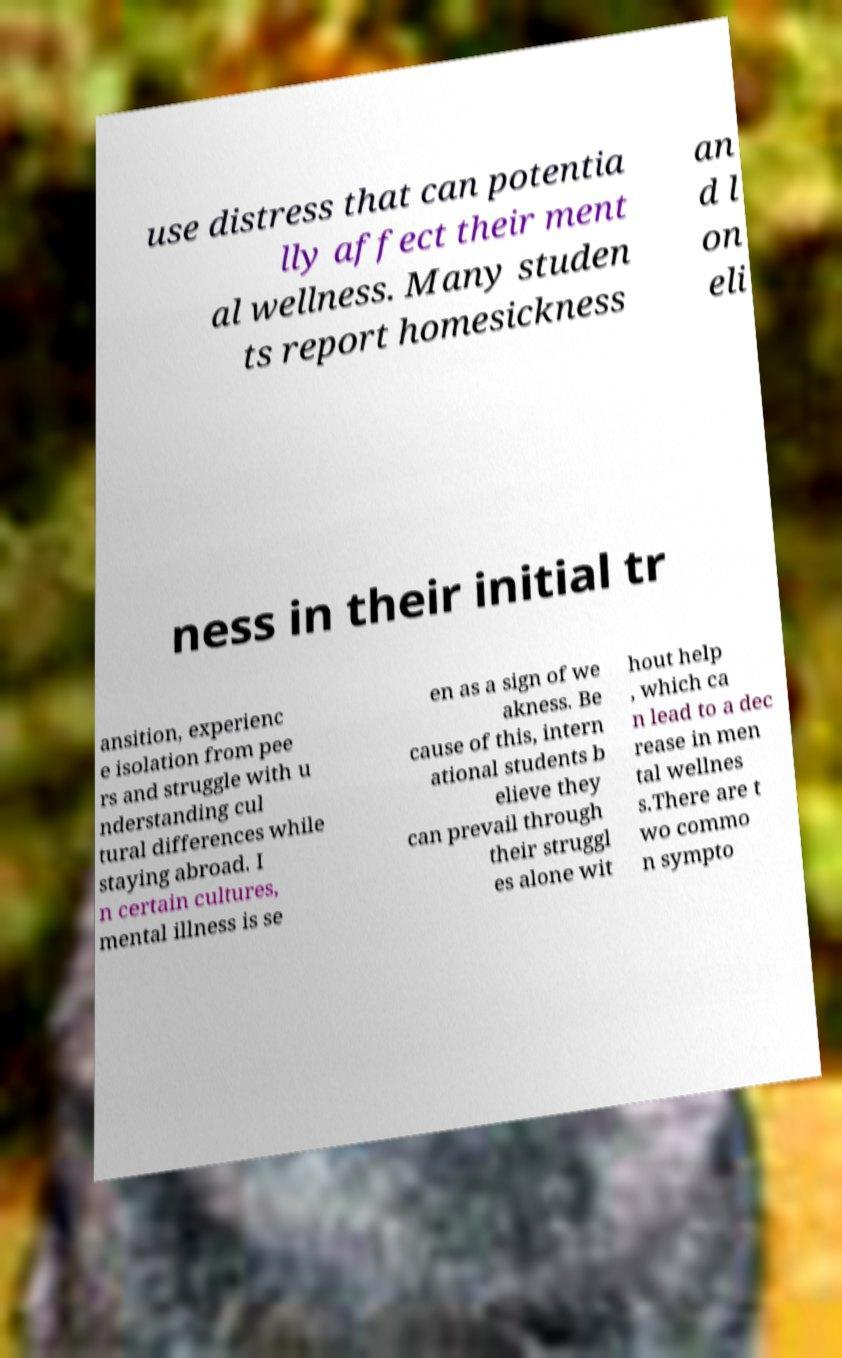Can you accurately transcribe the text from the provided image for me? use distress that can potentia lly affect their ment al wellness. Many studen ts report homesickness an d l on eli ness in their initial tr ansition, experienc e isolation from pee rs and struggle with u nderstanding cul tural differences while staying abroad. I n certain cultures, mental illness is se en as a sign of we akness. Be cause of this, intern ational students b elieve they can prevail through their struggl es alone wit hout help , which ca n lead to a dec rease in men tal wellnes s.There are t wo commo n sympto 